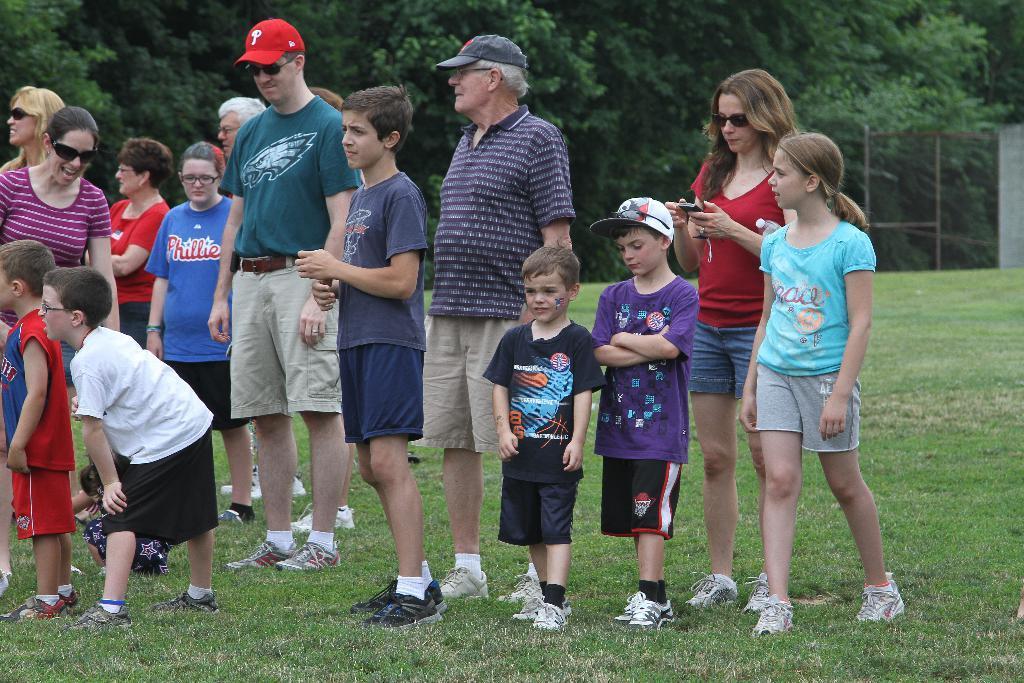In one or two sentences, can you explain what this image depicts? There are group of people standing. Here is the grass. This looks like a fence. These are the trees with branches and leaves. 